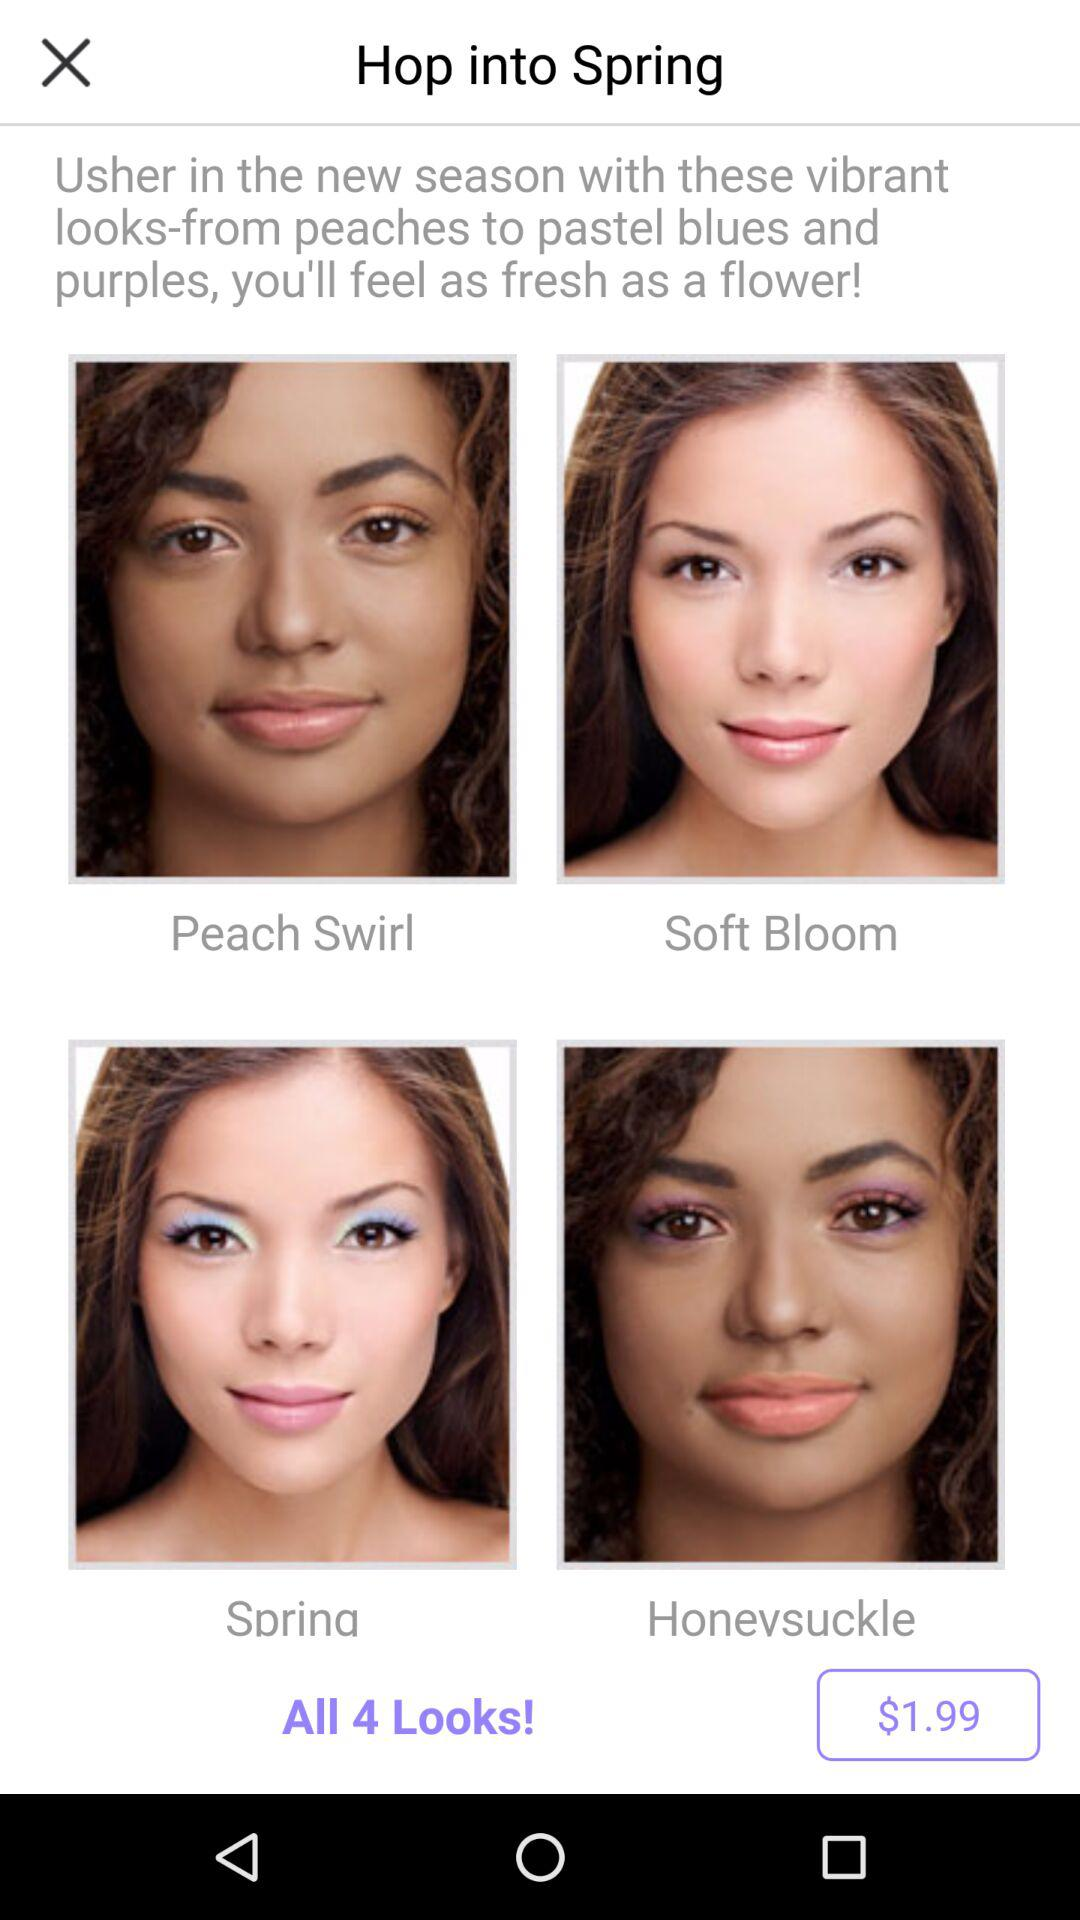What is the price for all 4 looks? The price for all 4 looks is $1.99. 